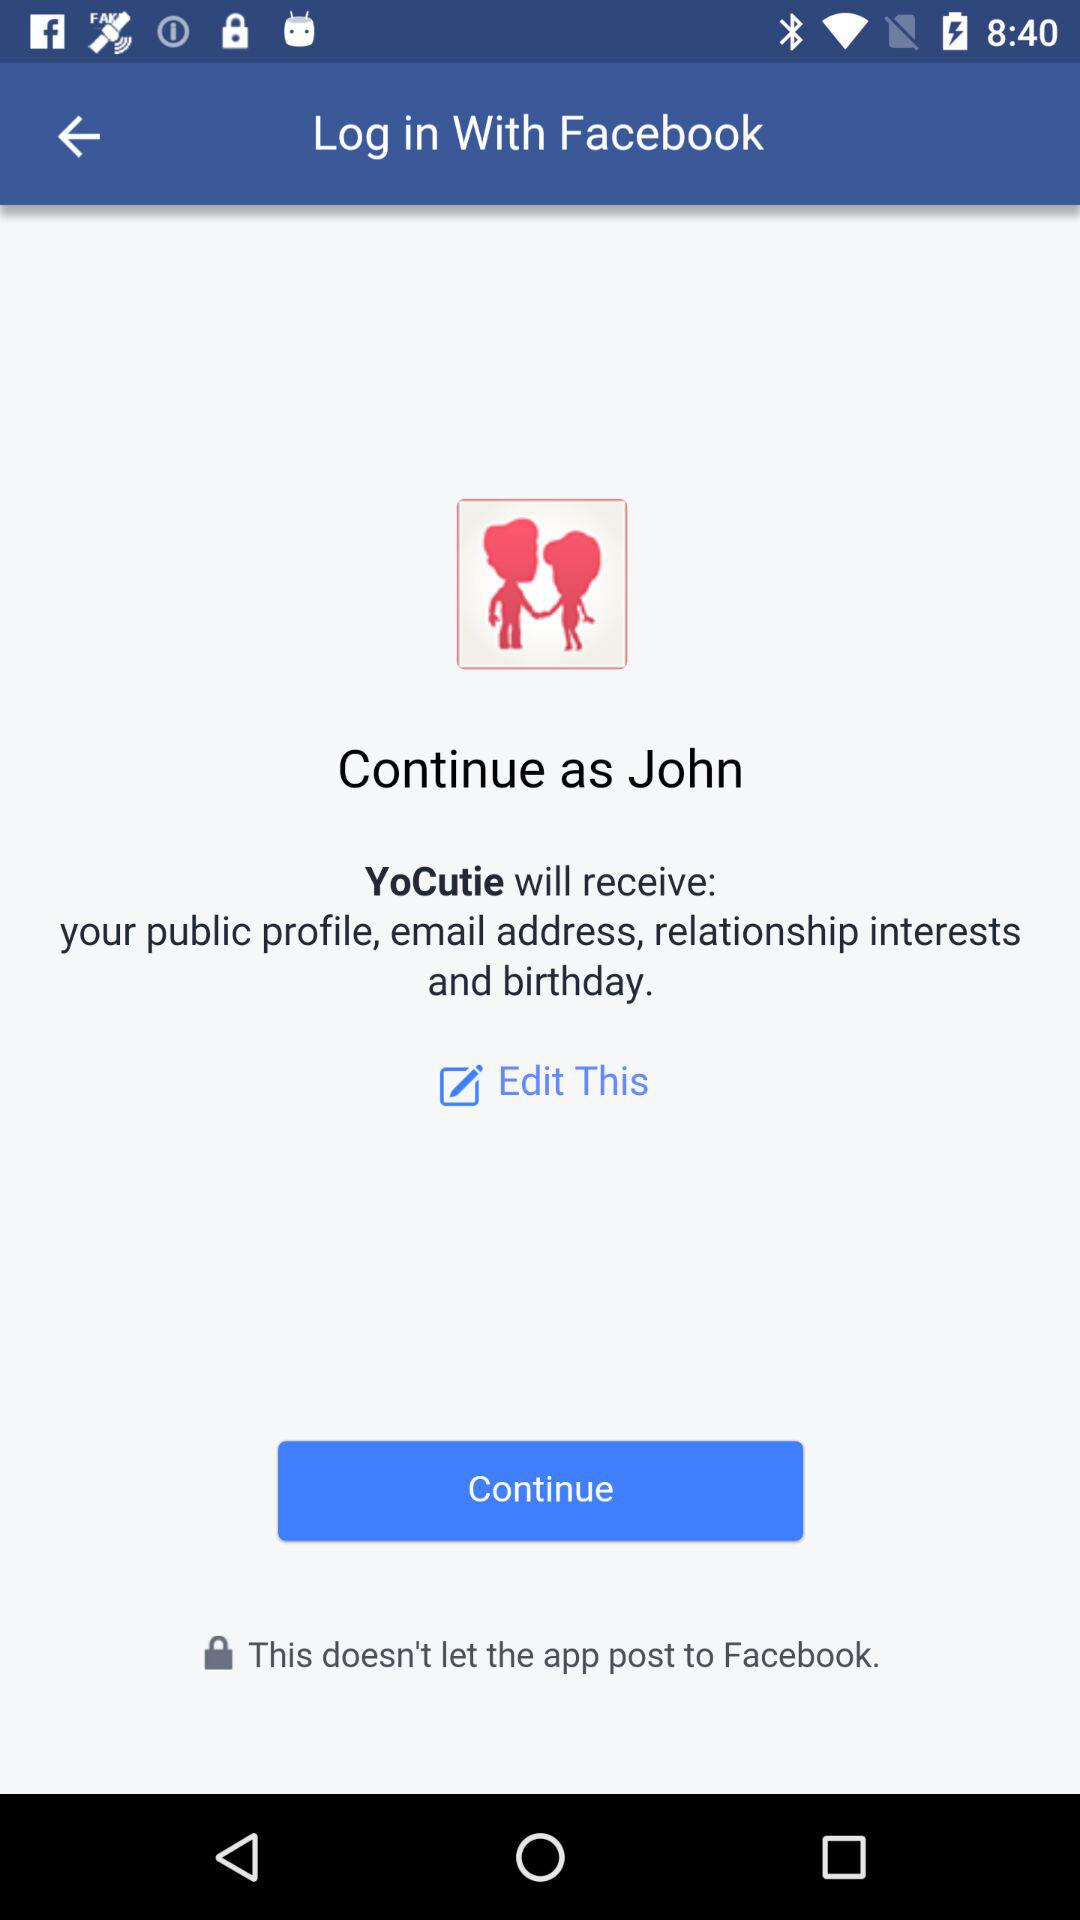Who will receive the public profile, relationship interests, birthday, and email address? The application that will receive the public profile, relationship interests, birthday, and email address is "YoCutie". 